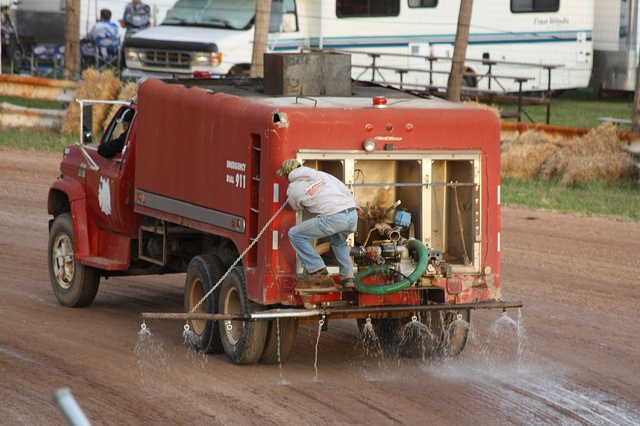Describe the objects in this image and their specific colors. I can see truck in lightgray, maroon, black, and gray tones, truck in lightgray, darkgray, black, and gray tones, people in lightgray, darkgray, and gray tones, people in lightgray, gray, darkgray, and black tones, and chair in lightgray, gray, black, navy, and darkblue tones in this image. 